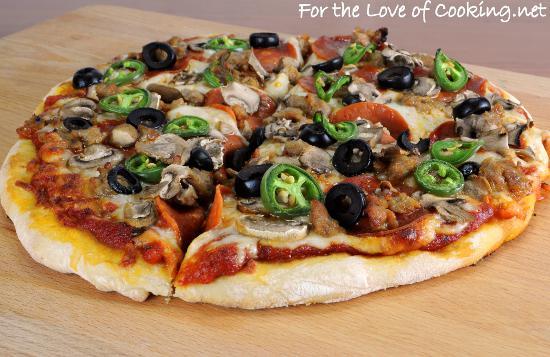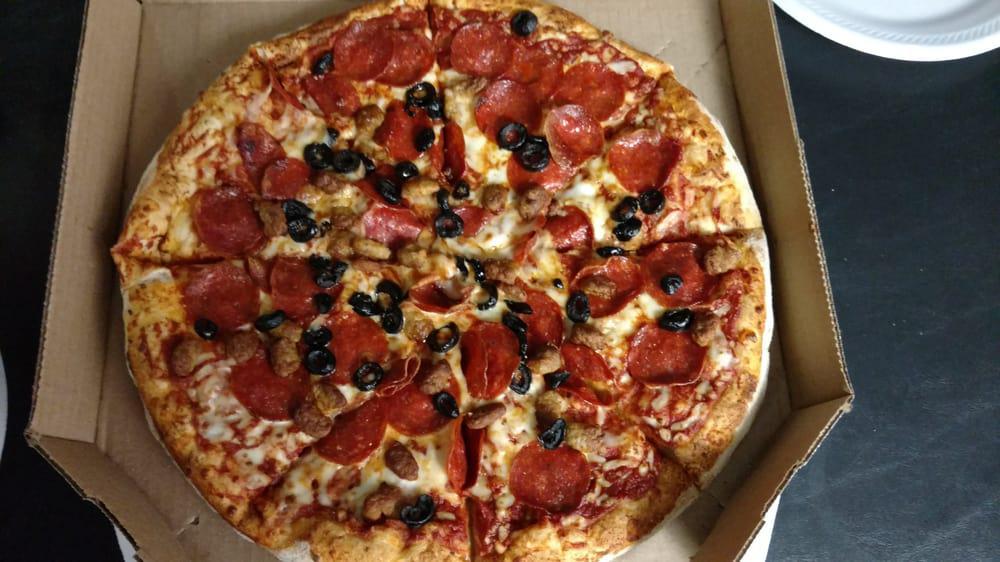The first image is the image on the left, the second image is the image on the right. Analyze the images presented: Is the assertion "One or more pizzas contain pepperoni." valid? Answer yes or no. Yes. The first image is the image on the left, the second image is the image on the right. Given the left and right images, does the statement "There are two circle pizzas uncut or all of it's slices are touching." hold true? Answer yes or no. Yes. 